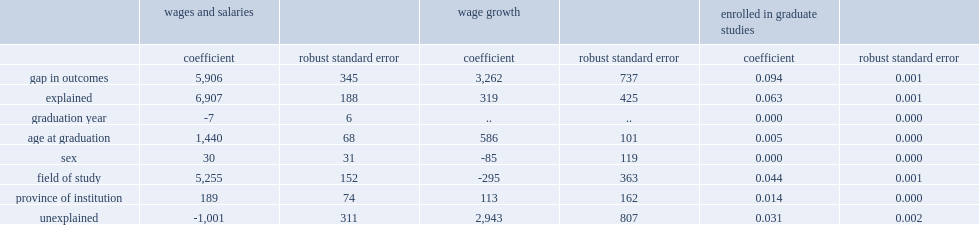After year of graduation, sex, age, age squared, province of institution, how much are field of study (denoted by the two-digit 2011 cip codes for primary groupings) accounted for cbd holders earn less than ubd holders? 1001. How much of the gap in the wages and salaries between cbd and ubd holders could be explained by differences in field of study choices? 5255.0. How many dollars could be explained by the fact that cbd holders are more than two years older than ubd holders? 1440.0. 